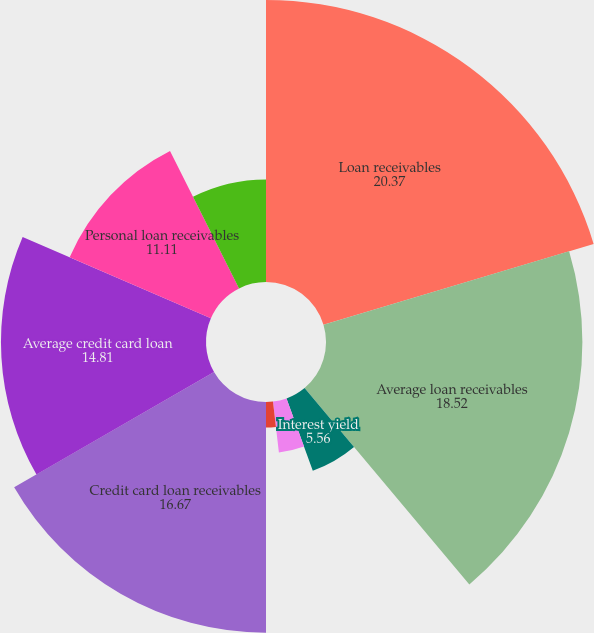<chart> <loc_0><loc_0><loc_500><loc_500><pie_chart><fcel>Loan receivables<fcel>Average loan receivables<fcel>Interest yield<fcel>Net principal charge-off rate<fcel>Delinquency rate (over 30<fcel>Delinquency rate (over 90<fcel>Credit card loan receivables<fcel>Average credit card loan<fcel>Personal loan receivables<fcel>Average personal loan<nl><fcel>20.37%<fcel>18.52%<fcel>5.56%<fcel>3.7%<fcel>1.85%<fcel>0.0%<fcel>16.67%<fcel>14.81%<fcel>11.11%<fcel>7.41%<nl></chart> 